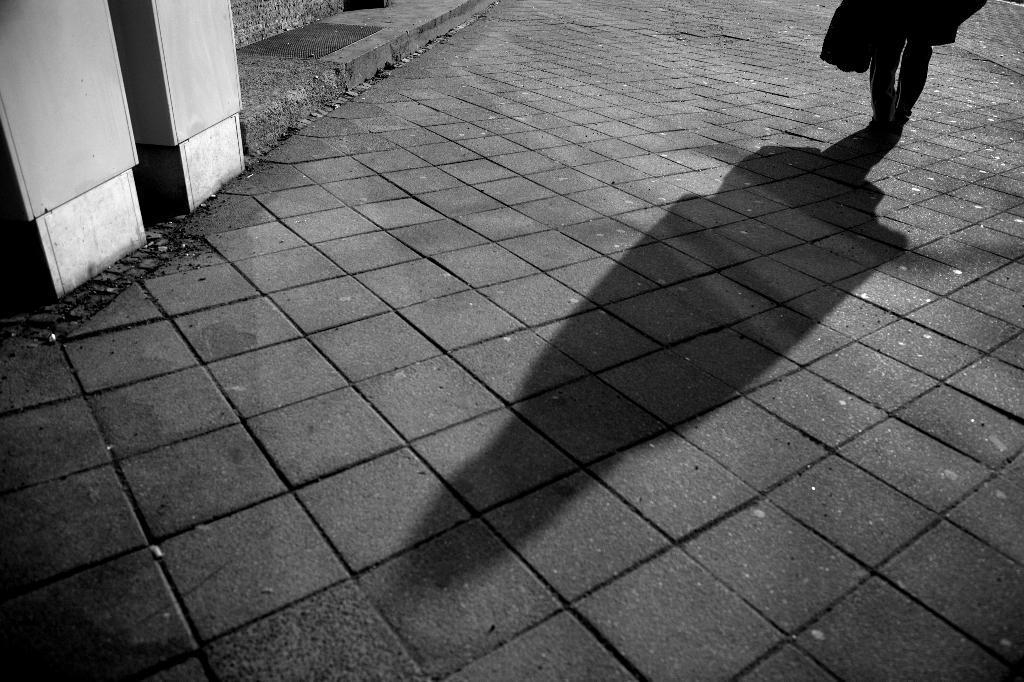Could you give a brief overview of what you see in this image? In this image we can see black and white picture of a person standing on the ground. 